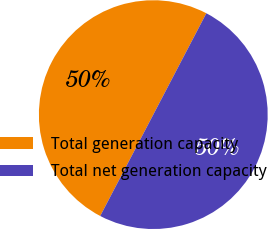Convert chart. <chart><loc_0><loc_0><loc_500><loc_500><pie_chart><fcel>Total generation capacity<fcel>Total net generation capacity<nl><fcel>50.0%<fcel>50.0%<nl></chart> 